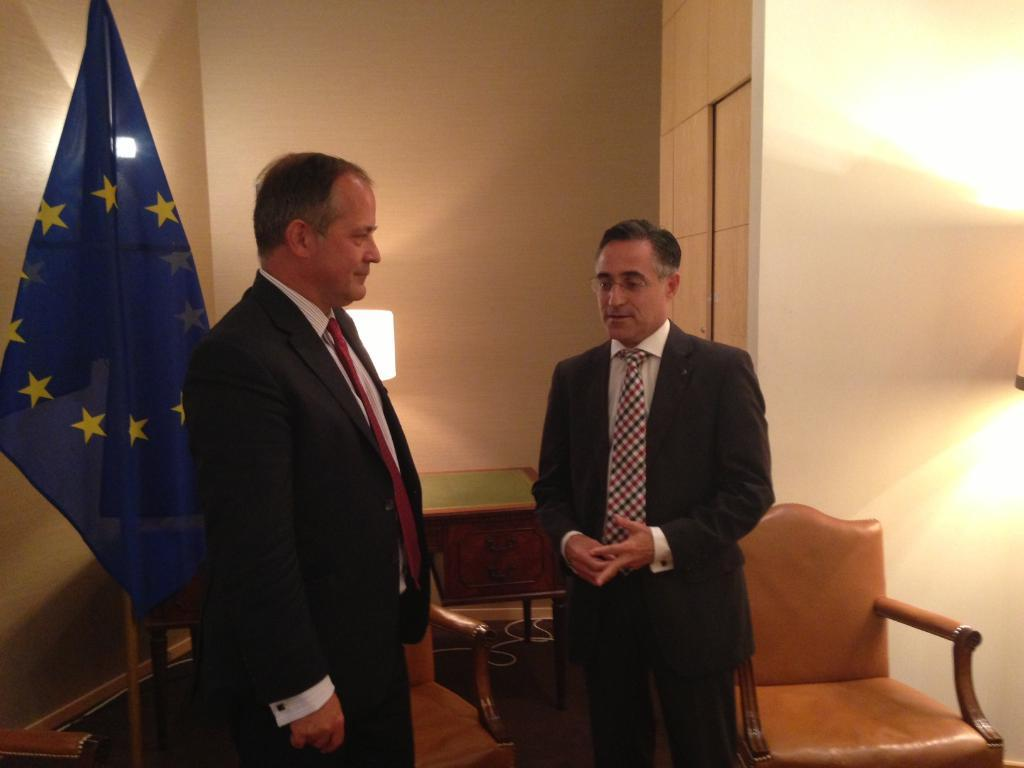How many people are in the image? There are two persons standing in the image. What is the surface they are standing on? The persons are standing on a floor. What can be seen in the background of the image? There is a wall, a chair, and a flag in the background of the image. What is the birth rate of the persons in the image? There is no information about the birth rate of the persons in the image, as it is not relevant to the visual content. 